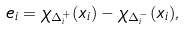<formula> <loc_0><loc_0><loc_500><loc_500>e _ { i } = \chi _ { \Delta _ { i } ^ { + } } ( x _ { i } ) - \chi _ { \Delta _ { i } ^ { - } } ( x _ { i } ) ,</formula> 